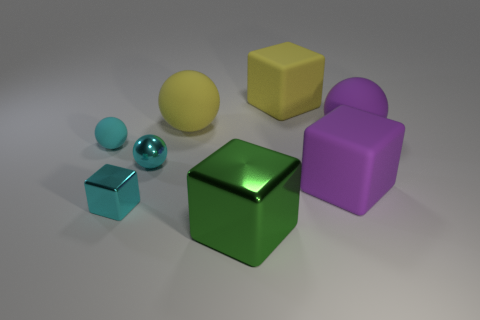Is the number of green metal cubes that are in front of the green metallic thing greater than the number of small cyan cubes?
Offer a terse response. No. Is there anything else that has the same color as the shiny ball?
Give a very brief answer. Yes. There is a yellow thing that is the same material as the big yellow sphere; what is its shape?
Give a very brief answer. Cube. Are the big purple object that is in front of the big purple matte sphere and the tiny cyan block made of the same material?
Provide a short and direct response. No. There is a small matte object that is the same color as the small metallic sphere; what is its shape?
Your answer should be very brief. Sphere. Does the big cube that is on the right side of the yellow matte block have the same color as the large rubber object left of the green thing?
Give a very brief answer. No. What number of matte objects are behind the small rubber object and on the left side of the purple ball?
Your answer should be very brief. 2. What is the material of the big purple sphere?
Offer a terse response. Rubber. There is a green shiny object that is the same size as the yellow sphere; what is its shape?
Make the answer very short. Cube. Does the ball that is in front of the small cyan rubber thing have the same material as the yellow thing left of the yellow cube?
Your answer should be compact. No. 